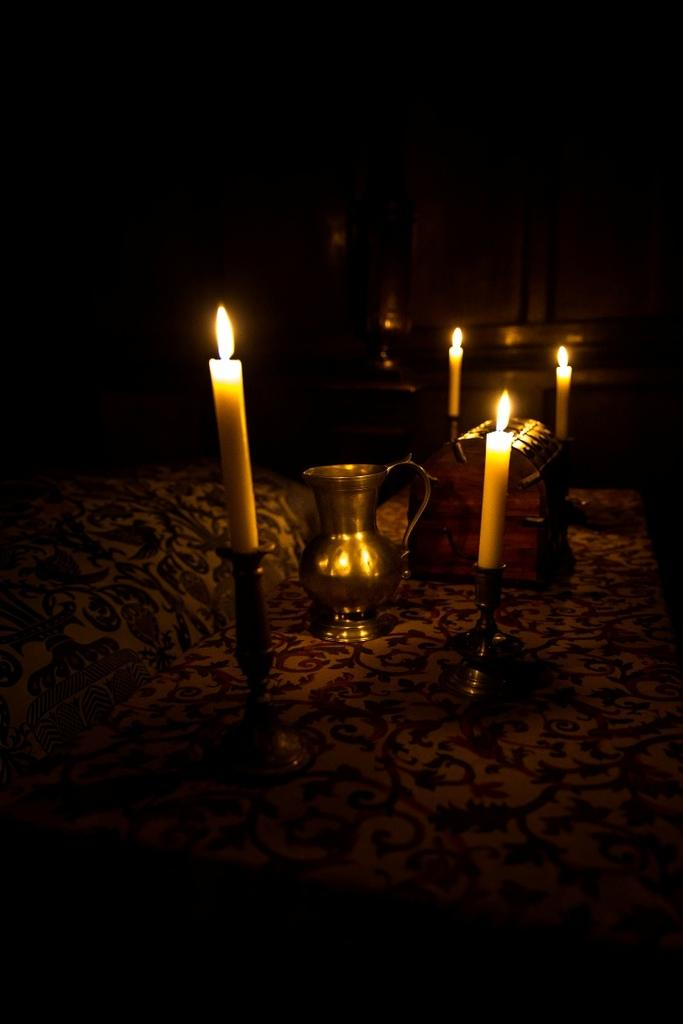How many candles are present in the image? There are 4 candles in the image. What other object can be seen in the image besides the candles? There is a jug in the image. What type of brush is used to light the candles in the image? There is no brush present in the image, and the candles are not being lit. What type of quill is used to write on the candles in the image? There is no quill present in the image, and the candles are not being written on. 